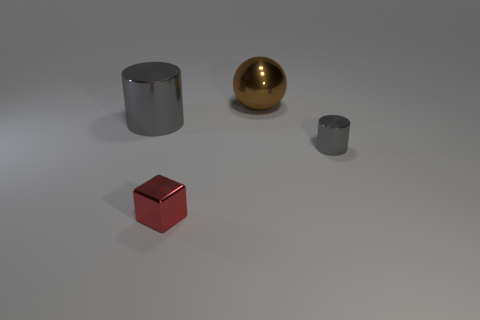What might be the function of these objects in a real-world setting? These objects seem to be basic geometric shapes that might serve educational or decorative purposes. The cylinders could be parts of a larger structure or possibly containers, while the sphere and cube could serve as models for academic purposes, such as in a classroom setting to teach geometry or as simple aesthetically pleasing sculptures. 